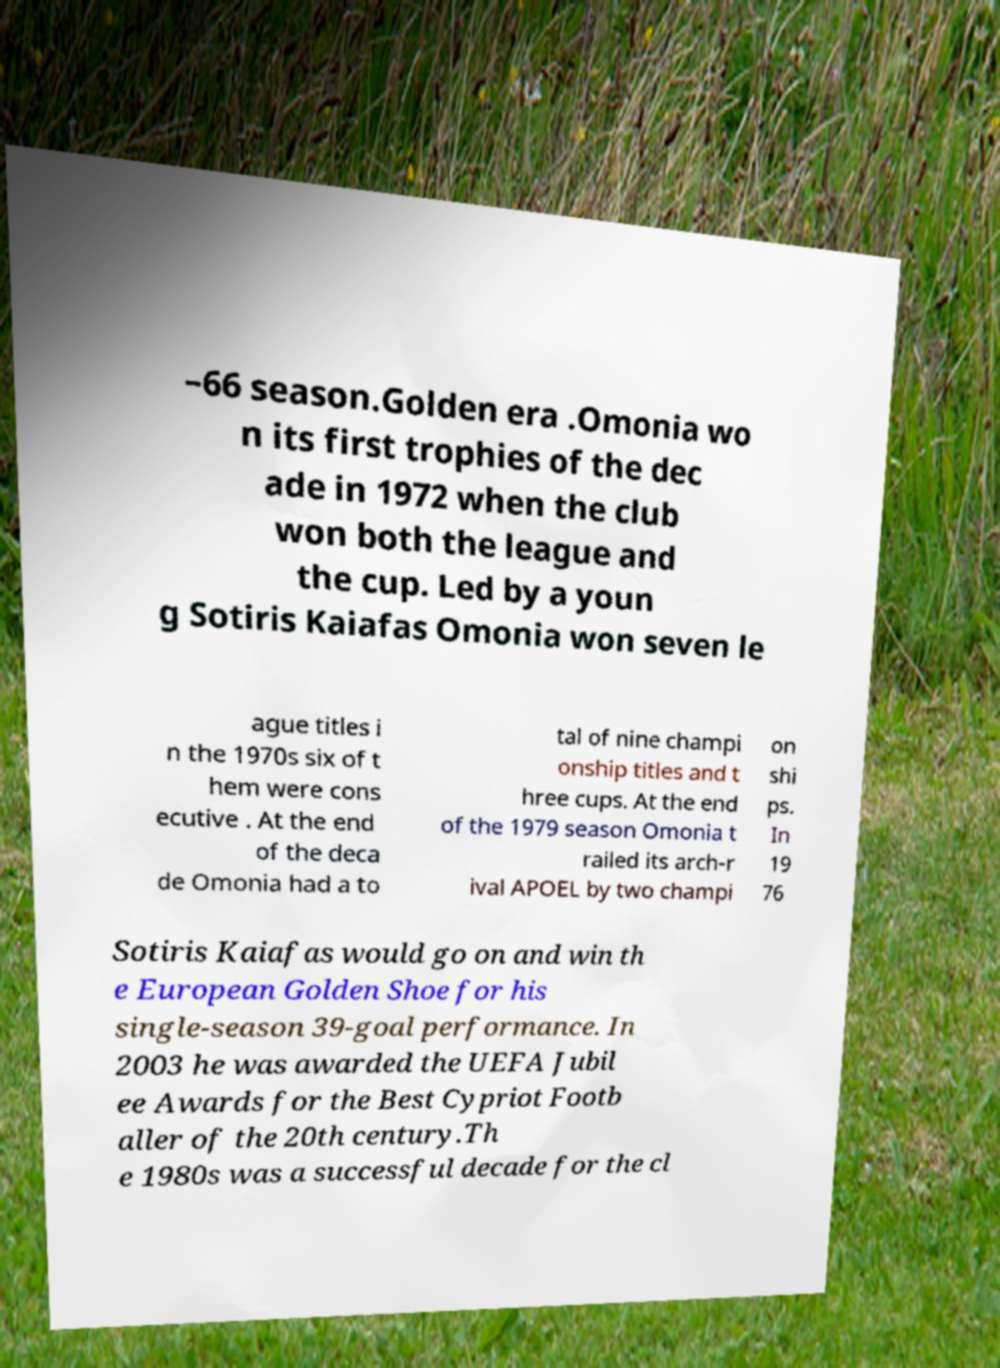Can you read and provide the text displayed in the image?This photo seems to have some interesting text. Can you extract and type it out for me? –66 season.Golden era .Omonia wo n its first trophies of the dec ade in 1972 when the club won both the league and the cup. Led by a youn g Sotiris Kaiafas Omonia won seven le ague titles i n the 1970s six of t hem were cons ecutive . At the end of the deca de Omonia had a to tal of nine champi onship titles and t hree cups. At the end of the 1979 season Omonia t railed its arch-r ival APOEL by two champi on shi ps. In 19 76 Sotiris Kaiafas would go on and win th e European Golden Shoe for his single-season 39-goal performance. In 2003 he was awarded the UEFA Jubil ee Awards for the Best Cypriot Footb aller of the 20th century.Th e 1980s was a successful decade for the cl 